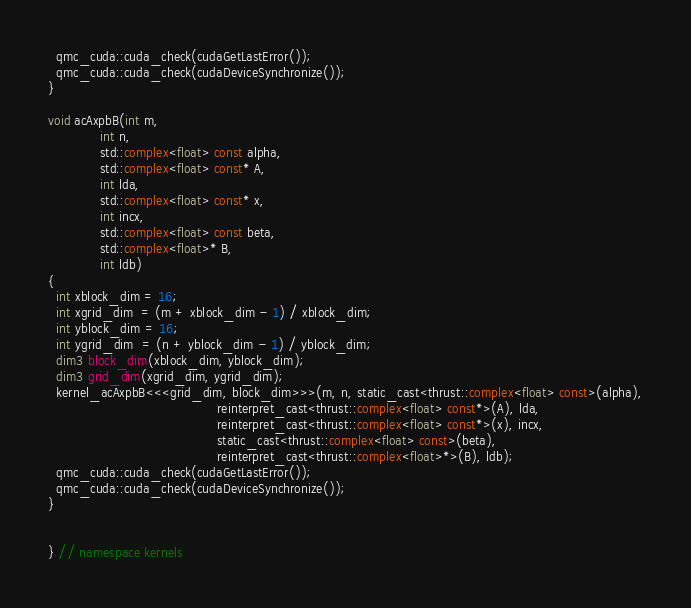Convert code to text. <code><loc_0><loc_0><loc_500><loc_500><_Cuda_>  qmc_cuda::cuda_check(cudaGetLastError());
  qmc_cuda::cuda_check(cudaDeviceSynchronize());
}

void acAxpbB(int m,
             int n,
             std::complex<float> const alpha,
             std::complex<float> const* A,
             int lda,
             std::complex<float> const* x,
             int incx,
             std::complex<float> const beta,
             std::complex<float>* B,
             int ldb)
{
  int xblock_dim = 16;
  int xgrid_dim  = (m + xblock_dim - 1) / xblock_dim;
  int yblock_dim = 16;
  int ygrid_dim  = (n + yblock_dim - 1) / yblock_dim;
  dim3 block_dim(xblock_dim, yblock_dim);
  dim3 grid_dim(xgrid_dim, ygrid_dim);
  kernel_acAxpbB<<<grid_dim, block_dim>>>(m, n, static_cast<thrust::complex<float> const>(alpha),
                                          reinterpret_cast<thrust::complex<float> const*>(A), lda,
                                          reinterpret_cast<thrust::complex<float> const*>(x), incx,
                                          static_cast<thrust::complex<float> const>(beta),
                                          reinterpret_cast<thrust::complex<float>*>(B), ldb);
  qmc_cuda::cuda_check(cudaGetLastError());
  qmc_cuda::cuda_check(cudaDeviceSynchronize());
}


} // namespace kernels
</code> 